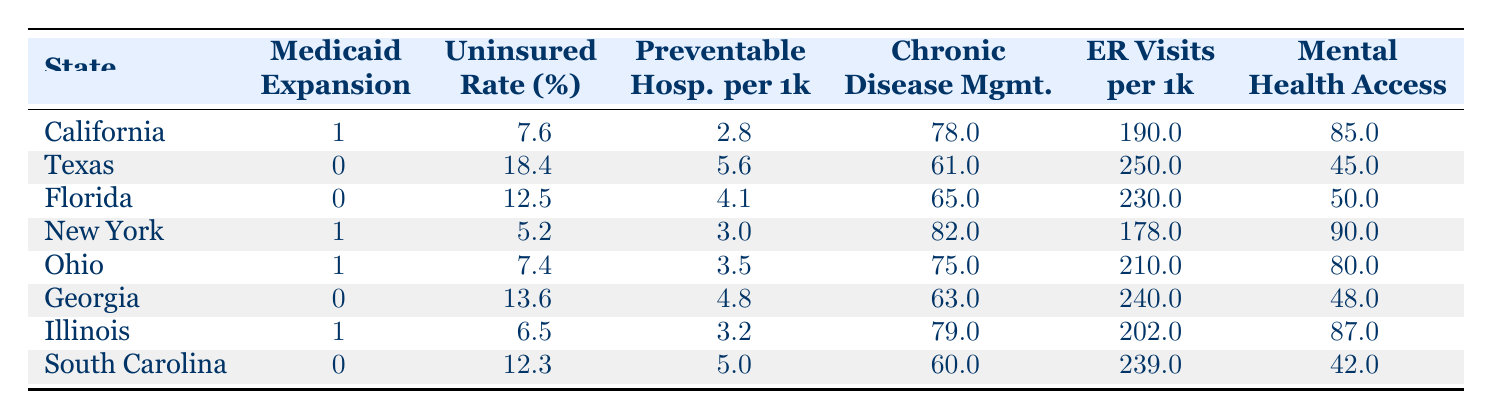What is the uninsured rate in California? The table shows that California has an uninsured rate of 7.6%. We can directly read this value from the corresponding row where California is listed.
Answer: 7.6% Which state has the highest uninsured rate? To find the state with the highest uninsured rate, we compare the uninsured rates of all states in the table. Texas has the highest uninsured rate at 18.4%.
Answer: Texas What is the average number of emergency room visits per 1000 for states with Medicaid expansion? The states with Medicaid expansion are California, New York, Ohio, and Illinois. Their emergency room visits per 1000 are 190, 178, 210, and 202, respectively. We add these values: 190 + 178 + 210 + 202 = 780. Then, we divide by the number of states (4): 780 / 4 = 195.
Answer: 195 Is mental health access better in states with Medicaid expansion compared to those without? We compare the mental health access percentages: California (85), New York (90), Ohio (80), and Illinois (87) for states with expansion versus Texas (45), Florida (50), Georgia (48), and South Carolina (42) for those without. The average for those with expansion is (85 + 90 + 80 + 87) / 4 = 85.5%. For those without, it is (45 + 50 + 48 + 42) / 4 = 46.25%. Therefore, mental health access is better in states with expansion.
Answer: Yes How many chronic disease management scores are above 75 among the states with Medicaid expansion? We refer to the chronic disease management scores for states with expansion: California (78), New York (82), Ohio (75), and Illinois (79). Since all but Ohio are above 75, we count 3 states.
Answer: 3 